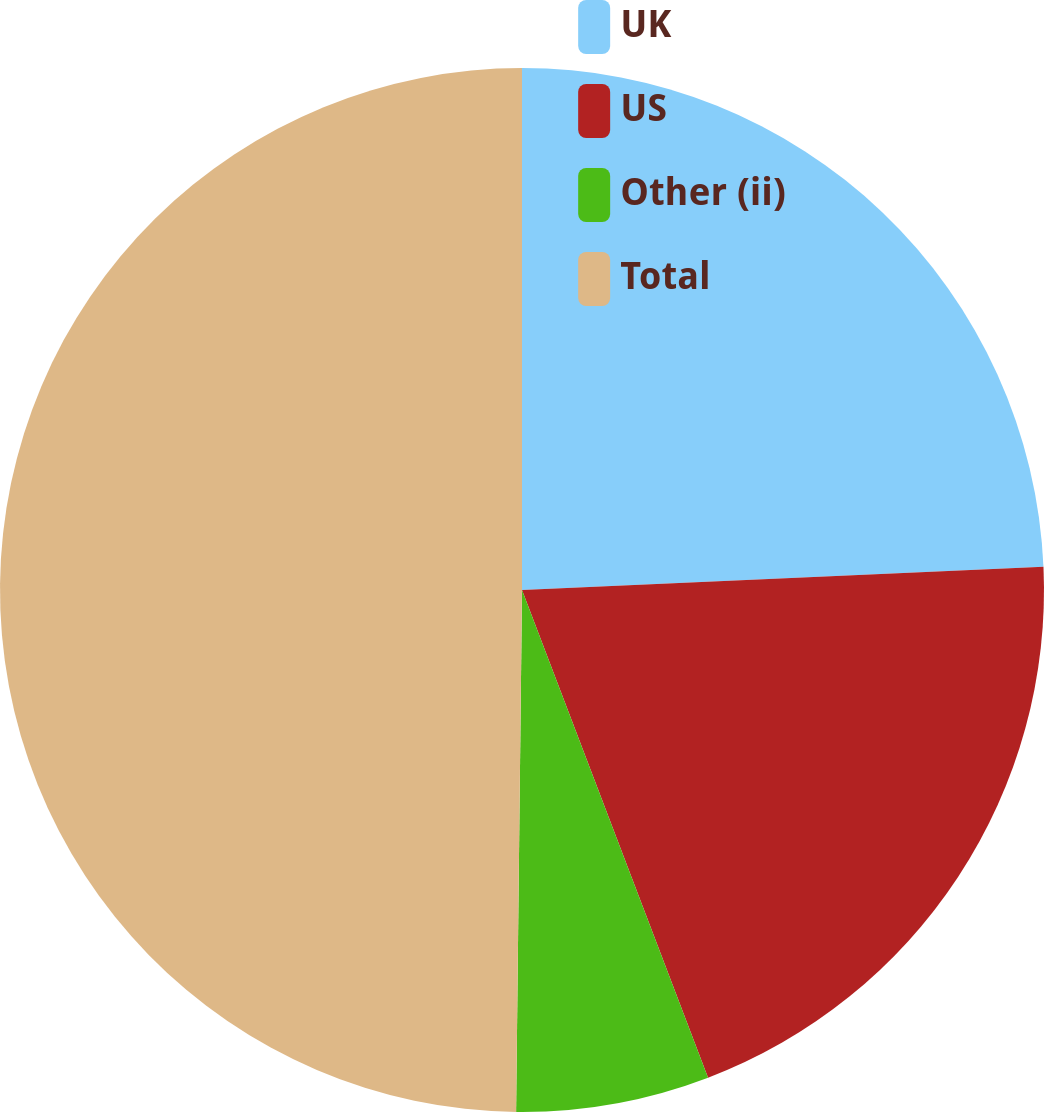Convert chart. <chart><loc_0><loc_0><loc_500><loc_500><pie_chart><fcel>UK<fcel>US<fcel>Other (ii)<fcel>Total<nl><fcel>24.29%<fcel>19.91%<fcel>5.98%<fcel>49.82%<nl></chart> 